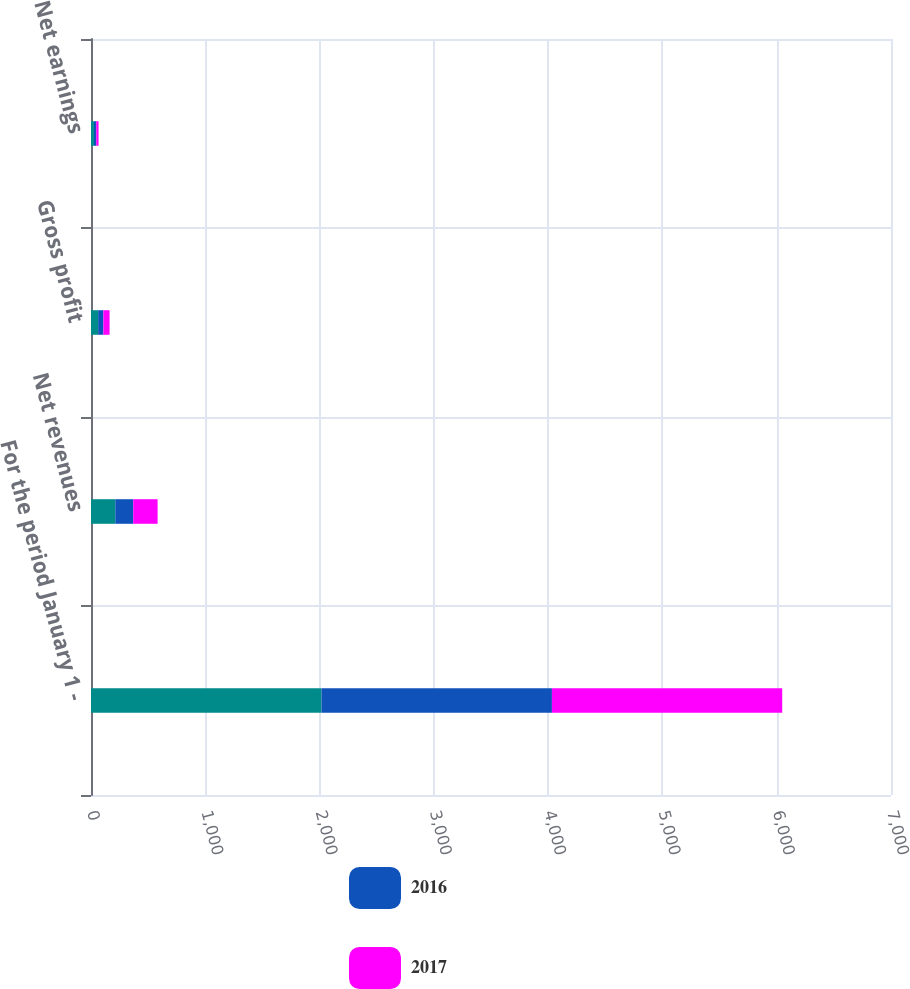<chart> <loc_0><loc_0><loc_500><loc_500><stacked_bar_chart><ecel><fcel>For the period January 1 -<fcel>Net revenues<fcel>Gross profit<fcel>Net earnings<nl><fcel>nan<fcel>2017<fcel>212.5<fcel>62.6<fcel>25.7<nl><fcel>2016<fcel>2016<fcel>156.7<fcel>45.7<fcel>20.3<nl><fcel>2017<fcel>2015<fcel>213.7<fcel>54.3<fcel>20.1<nl></chart> 